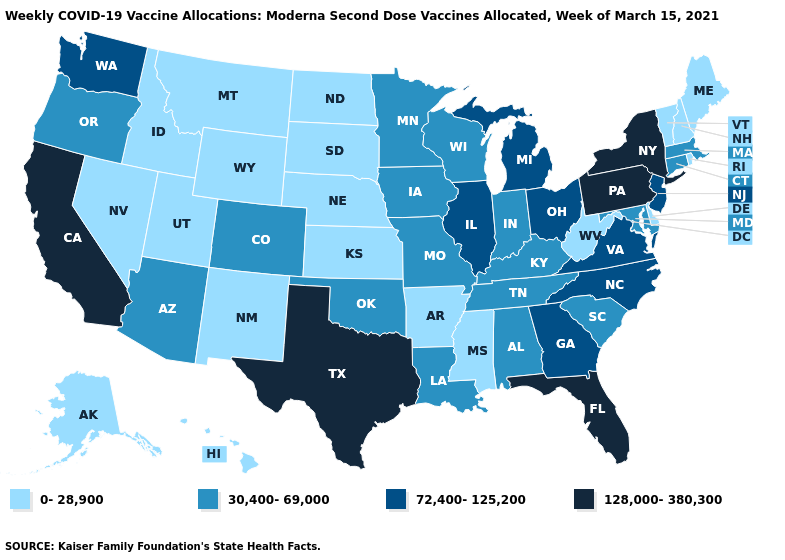How many symbols are there in the legend?
Quick response, please. 4. Does New York have the lowest value in the Northeast?
Concise answer only. No. Name the states that have a value in the range 0-28,900?
Write a very short answer. Alaska, Arkansas, Delaware, Hawaii, Idaho, Kansas, Maine, Mississippi, Montana, Nebraska, Nevada, New Hampshire, New Mexico, North Dakota, Rhode Island, South Dakota, Utah, Vermont, West Virginia, Wyoming. What is the value of Vermont?
Answer briefly. 0-28,900. Name the states that have a value in the range 30,400-69,000?
Quick response, please. Alabama, Arizona, Colorado, Connecticut, Indiana, Iowa, Kentucky, Louisiana, Maryland, Massachusetts, Minnesota, Missouri, Oklahoma, Oregon, South Carolina, Tennessee, Wisconsin. How many symbols are there in the legend?
Concise answer only. 4. Among the states that border South Dakota , does Montana have the highest value?
Give a very brief answer. No. Is the legend a continuous bar?
Write a very short answer. No. Name the states that have a value in the range 128,000-380,300?
Quick response, please. California, Florida, New York, Pennsylvania, Texas. Does Illinois have the highest value in the MidWest?
Concise answer only. Yes. Among the states that border South Dakota , which have the highest value?
Keep it brief. Iowa, Minnesota. Does Minnesota have a higher value than Washington?
Answer briefly. No. What is the value of Texas?
Short answer required. 128,000-380,300. Name the states that have a value in the range 72,400-125,200?
Concise answer only. Georgia, Illinois, Michigan, New Jersey, North Carolina, Ohio, Virginia, Washington. Name the states that have a value in the range 0-28,900?
Short answer required. Alaska, Arkansas, Delaware, Hawaii, Idaho, Kansas, Maine, Mississippi, Montana, Nebraska, Nevada, New Hampshire, New Mexico, North Dakota, Rhode Island, South Dakota, Utah, Vermont, West Virginia, Wyoming. 